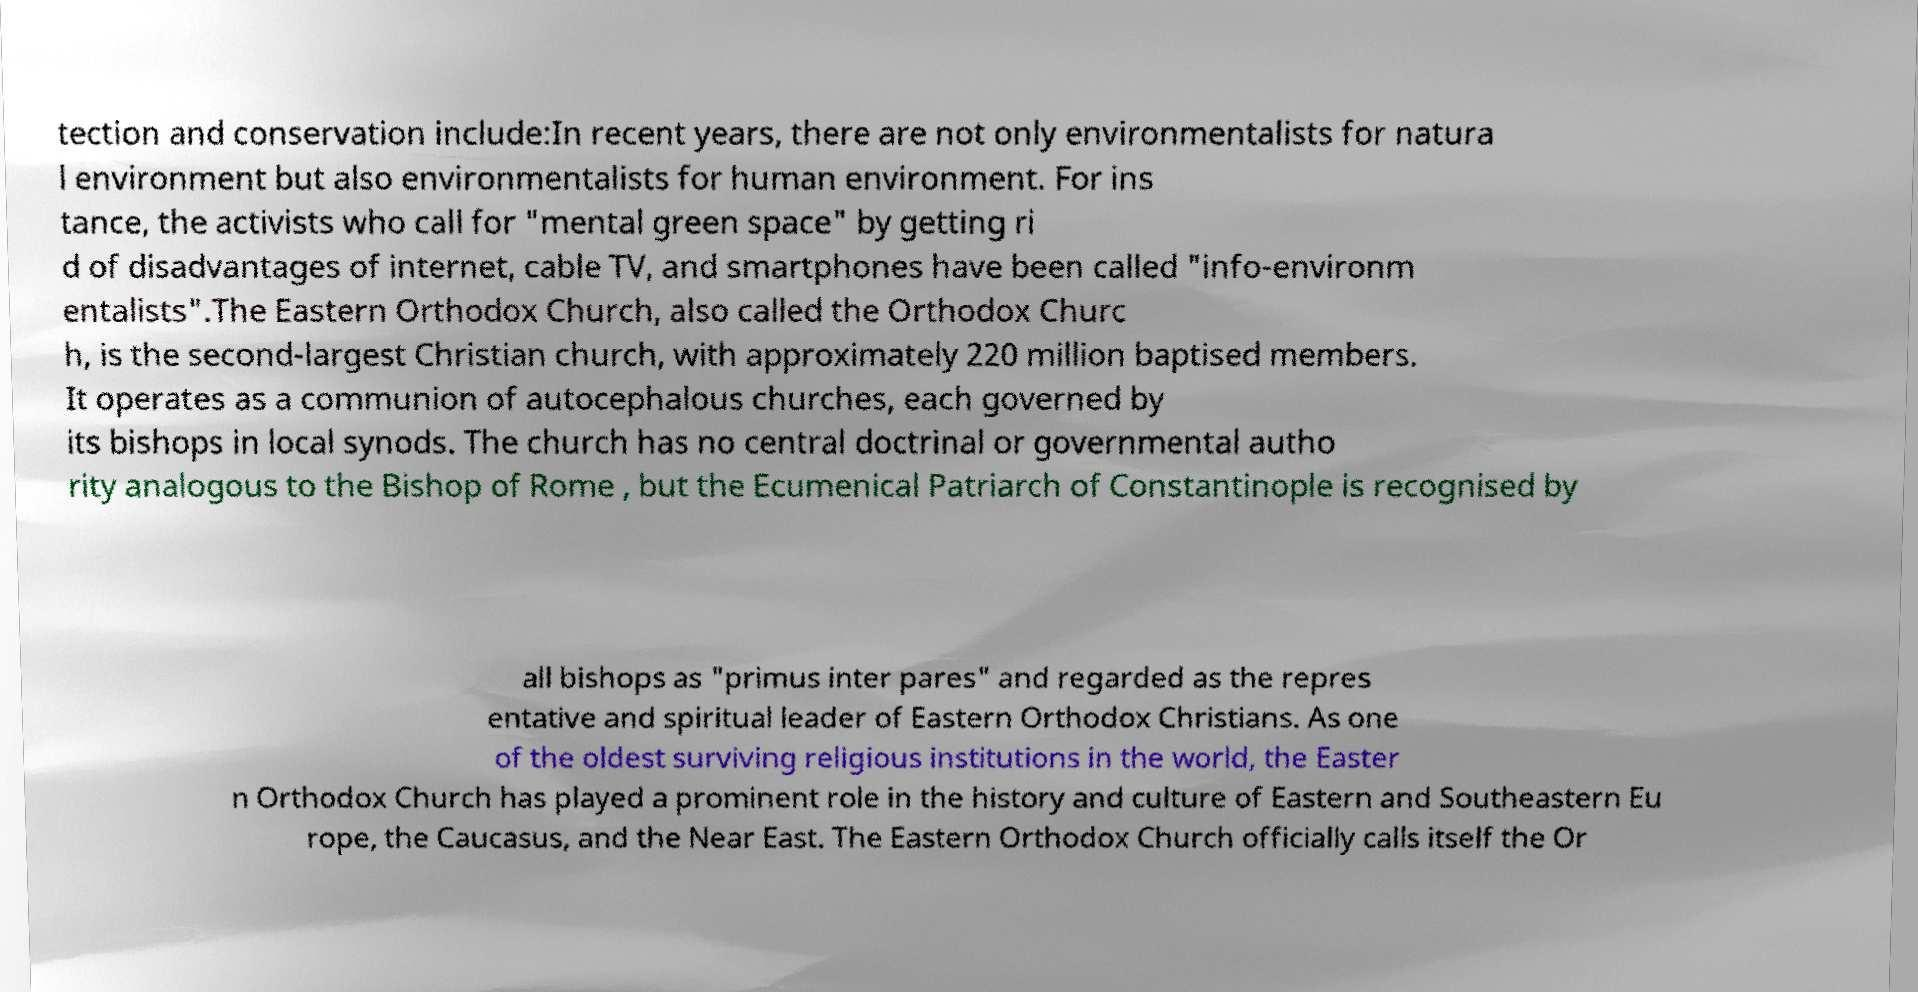For documentation purposes, I need the text within this image transcribed. Could you provide that? tection and conservation include:In recent years, there are not only environmentalists for natura l environment but also environmentalists for human environment. For ins tance, the activists who call for "mental green space" by getting ri d of disadvantages of internet, cable TV, and smartphones have been called "info-environm entalists".The Eastern Orthodox Church, also called the Orthodox Churc h, is the second-largest Christian church, with approximately 220 million baptised members. It operates as a communion of autocephalous churches, each governed by its bishops in local synods. The church has no central doctrinal or governmental autho rity analogous to the Bishop of Rome , but the Ecumenical Patriarch of Constantinople is recognised by all bishops as "primus inter pares" and regarded as the repres entative and spiritual leader of Eastern Orthodox Christians. As one of the oldest surviving religious institutions in the world, the Easter n Orthodox Church has played a prominent role in the history and culture of Eastern and Southeastern Eu rope, the Caucasus, and the Near East. The Eastern Orthodox Church officially calls itself the Or 